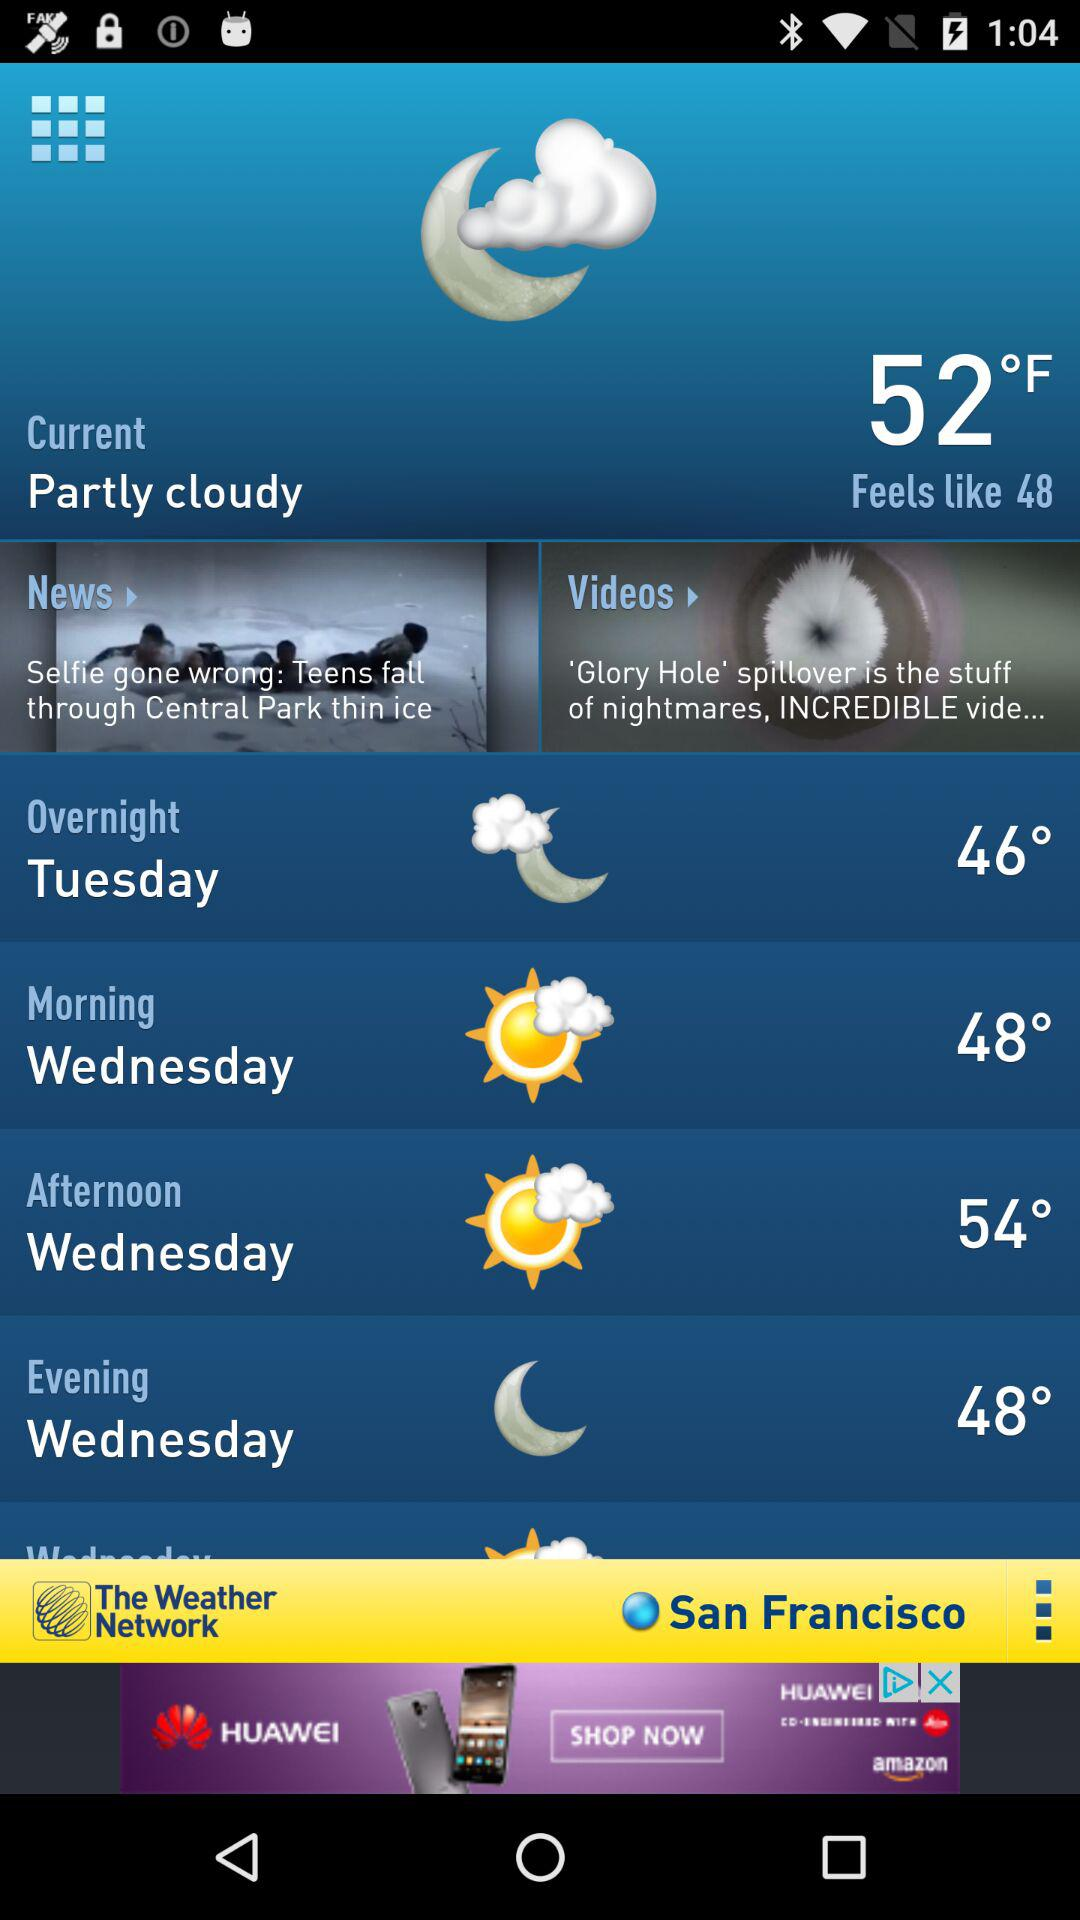What is the given day for the overnight? The given day is "Tuesday". 